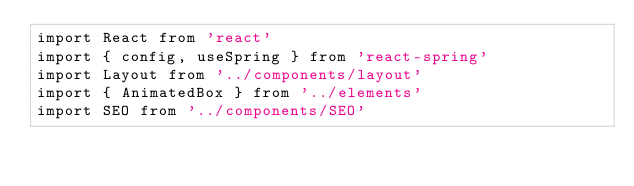<code> <loc_0><loc_0><loc_500><loc_500><_TypeScript_>import React from 'react'
import { config, useSpring } from 'react-spring'
import Layout from '../components/layout'
import { AnimatedBox } from '../elements'
import SEO from '../components/SEO'
</code> 